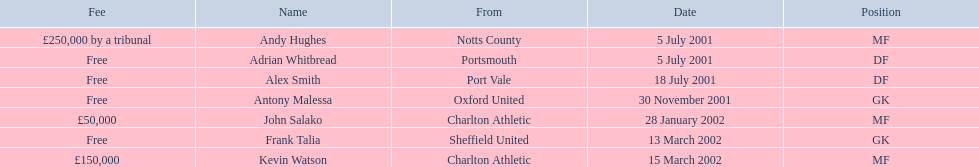Did andy hughes or john salako command the largest fee? Andy Hughes. I'm looking to parse the entire table for insights. Could you assist me with that? {'header': ['Fee', 'Name', 'From', 'Date', 'Position'], 'rows': [['£250,000 by a tribunal', 'Andy Hughes', 'Notts County', '5 July 2001', 'MF'], ['Free', 'Adrian Whitbread', 'Portsmouth', '5 July 2001', 'DF'], ['Free', 'Alex Smith', 'Port Vale', '18 July 2001', 'DF'], ['Free', 'Antony Malessa', 'Oxford United', '30 November 2001', 'GK'], ['£50,000', 'John Salako', 'Charlton Athletic', '28 January 2002', 'MF'], ['Free', 'Frank Talia', 'Sheffield United', '13 March 2002', 'GK'], ['£150,000', 'Kevin Watson', 'Charlton Athletic', '15 March 2002', 'MF']]} 